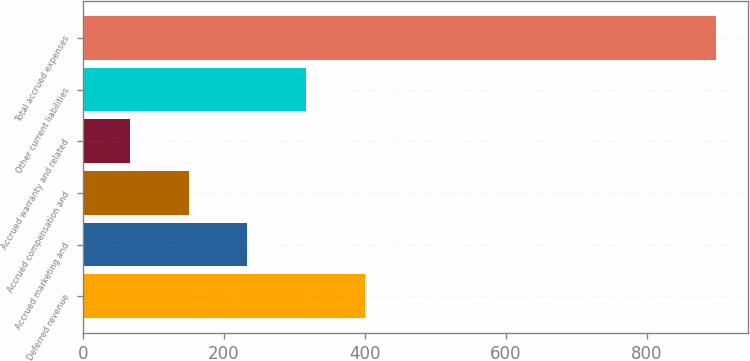Convert chart to OTSL. <chart><loc_0><loc_0><loc_500><loc_500><bar_chart><fcel>Deferred revenue<fcel>Accrued marketing and<fcel>Accrued compensation and<fcel>Accrued warranty and related<fcel>Other current liabilities<fcel>Total accrued expenses<nl><fcel>399.8<fcel>233.4<fcel>150.2<fcel>67<fcel>316.6<fcel>899<nl></chart> 